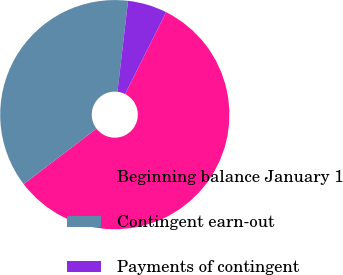Convert chart. <chart><loc_0><loc_0><loc_500><loc_500><pie_chart><fcel>Beginning balance January 1<fcel>Contingent earn-out<fcel>Payments of contingent<nl><fcel>57.25%<fcel>37.21%<fcel>5.54%<nl></chart> 